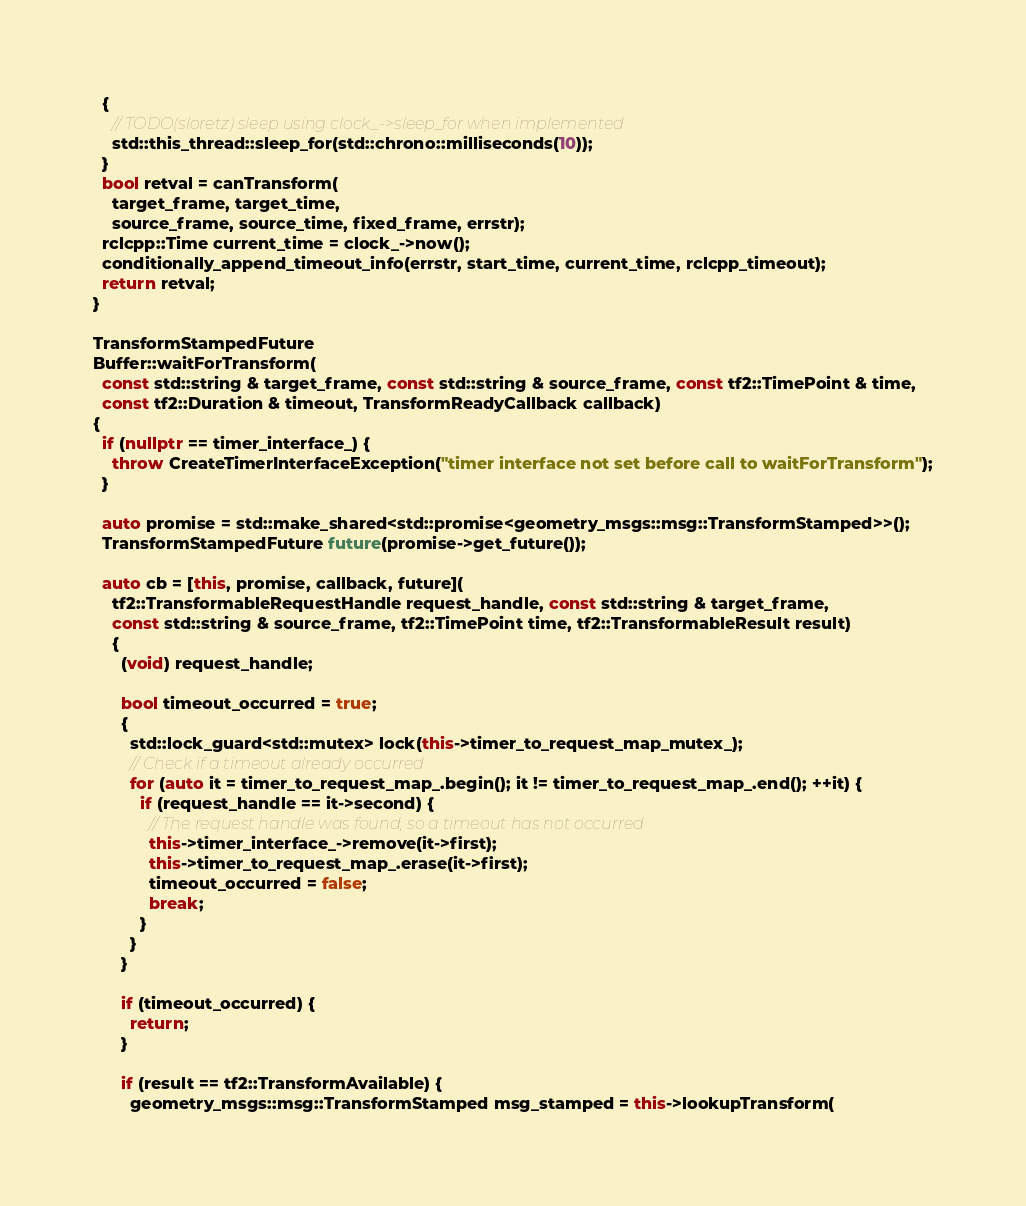Convert code to text. <code><loc_0><loc_0><loc_500><loc_500><_C++_>  {
    // TODO(sloretz) sleep using clock_->sleep_for when implemented
    std::this_thread::sleep_for(std::chrono::milliseconds(10));
  }
  bool retval = canTransform(
    target_frame, target_time,
    source_frame, source_time, fixed_frame, errstr);
  rclcpp::Time current_time = clock_->now();
  conditionally_append_timeout_info(errstr, start_time, current_time, rclcpp_timeout);
  return retval;
}

TransformStampedFuture
Buffer::waitForTransform(
  const std::string & target_frame, const std::string & source_frame, const tf2::TimePoint & time,
  const tf2::Duration & timeout, TransformReadyCallback callback)
{
  if (nullptr == timer_interface_) {
    throw CreateTimerInterfaceException("timer interface not set before call to waitForTransform");
  }

  auto promise = std::make_shared<std::promise<geometry_msgs::msg::TransformStamped>>();
  TransformStampedFuture future(promise->get_future());

  auto cb = [this, promise, callback, future](
    tf2::TransformableRequestHandle request_handle, const std::string & target_frame,
    const std::string & source_frame, tf2::TimePoint time, tf2::TransformableResult result)
    {
      (void) request_handle;

      bool timeout_occurred = true;
      {
        std::lock_guard<std::mutex> lock(this->timer_to_request_map_mutex_);
        // Check if a timeout already occurred
        for (auto it = timer_to_request_map_.begin(); it != timer_to_request_map_.end(); ++it) {
          if (request_handle == it->second) {
            // The request handle was found, so a timeout has not occurred
            this->timer_interface_->remove(it->first);
            this->timer_to_request_map_.erase(it->first);
            timeout_occurred = false;
            break;
          }
        }
      }

      if (timeout_occurred) {
        return;
      }

      if (result == tf2::TransformAvailable) {
        geometry_msgs::msg::TransformStamped msg_stamped = this->lookupTransform(</code> 